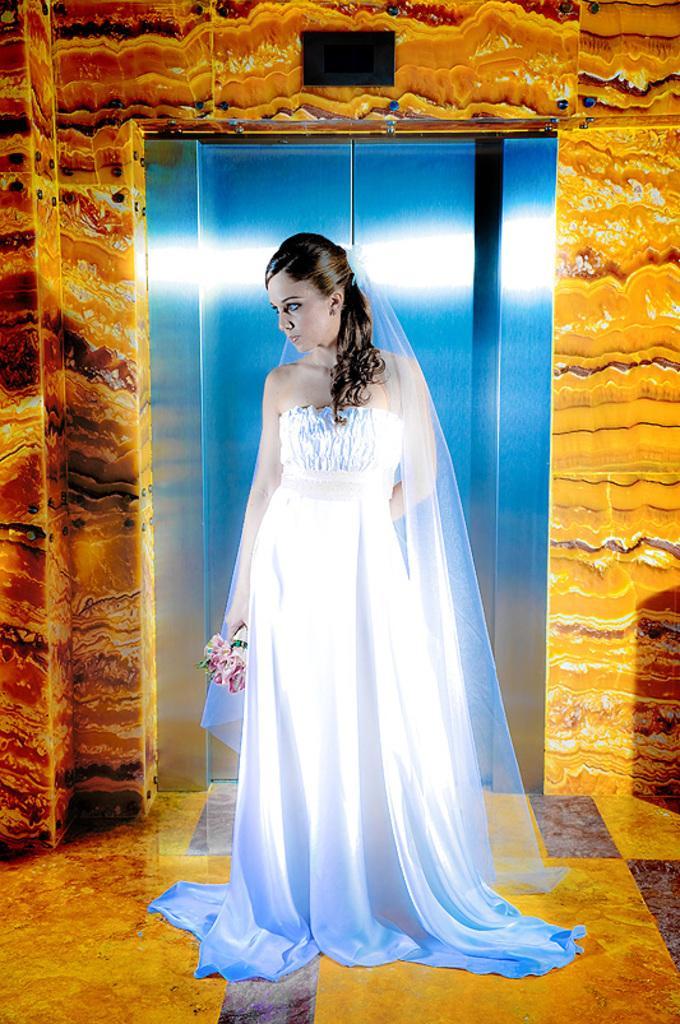How would you summarize this image in a sentence or two? In the center of the image there is a lady standing wearing a white color dress. In the background of the image there is wall. There is lift. At the bottom of the image there is floor. 